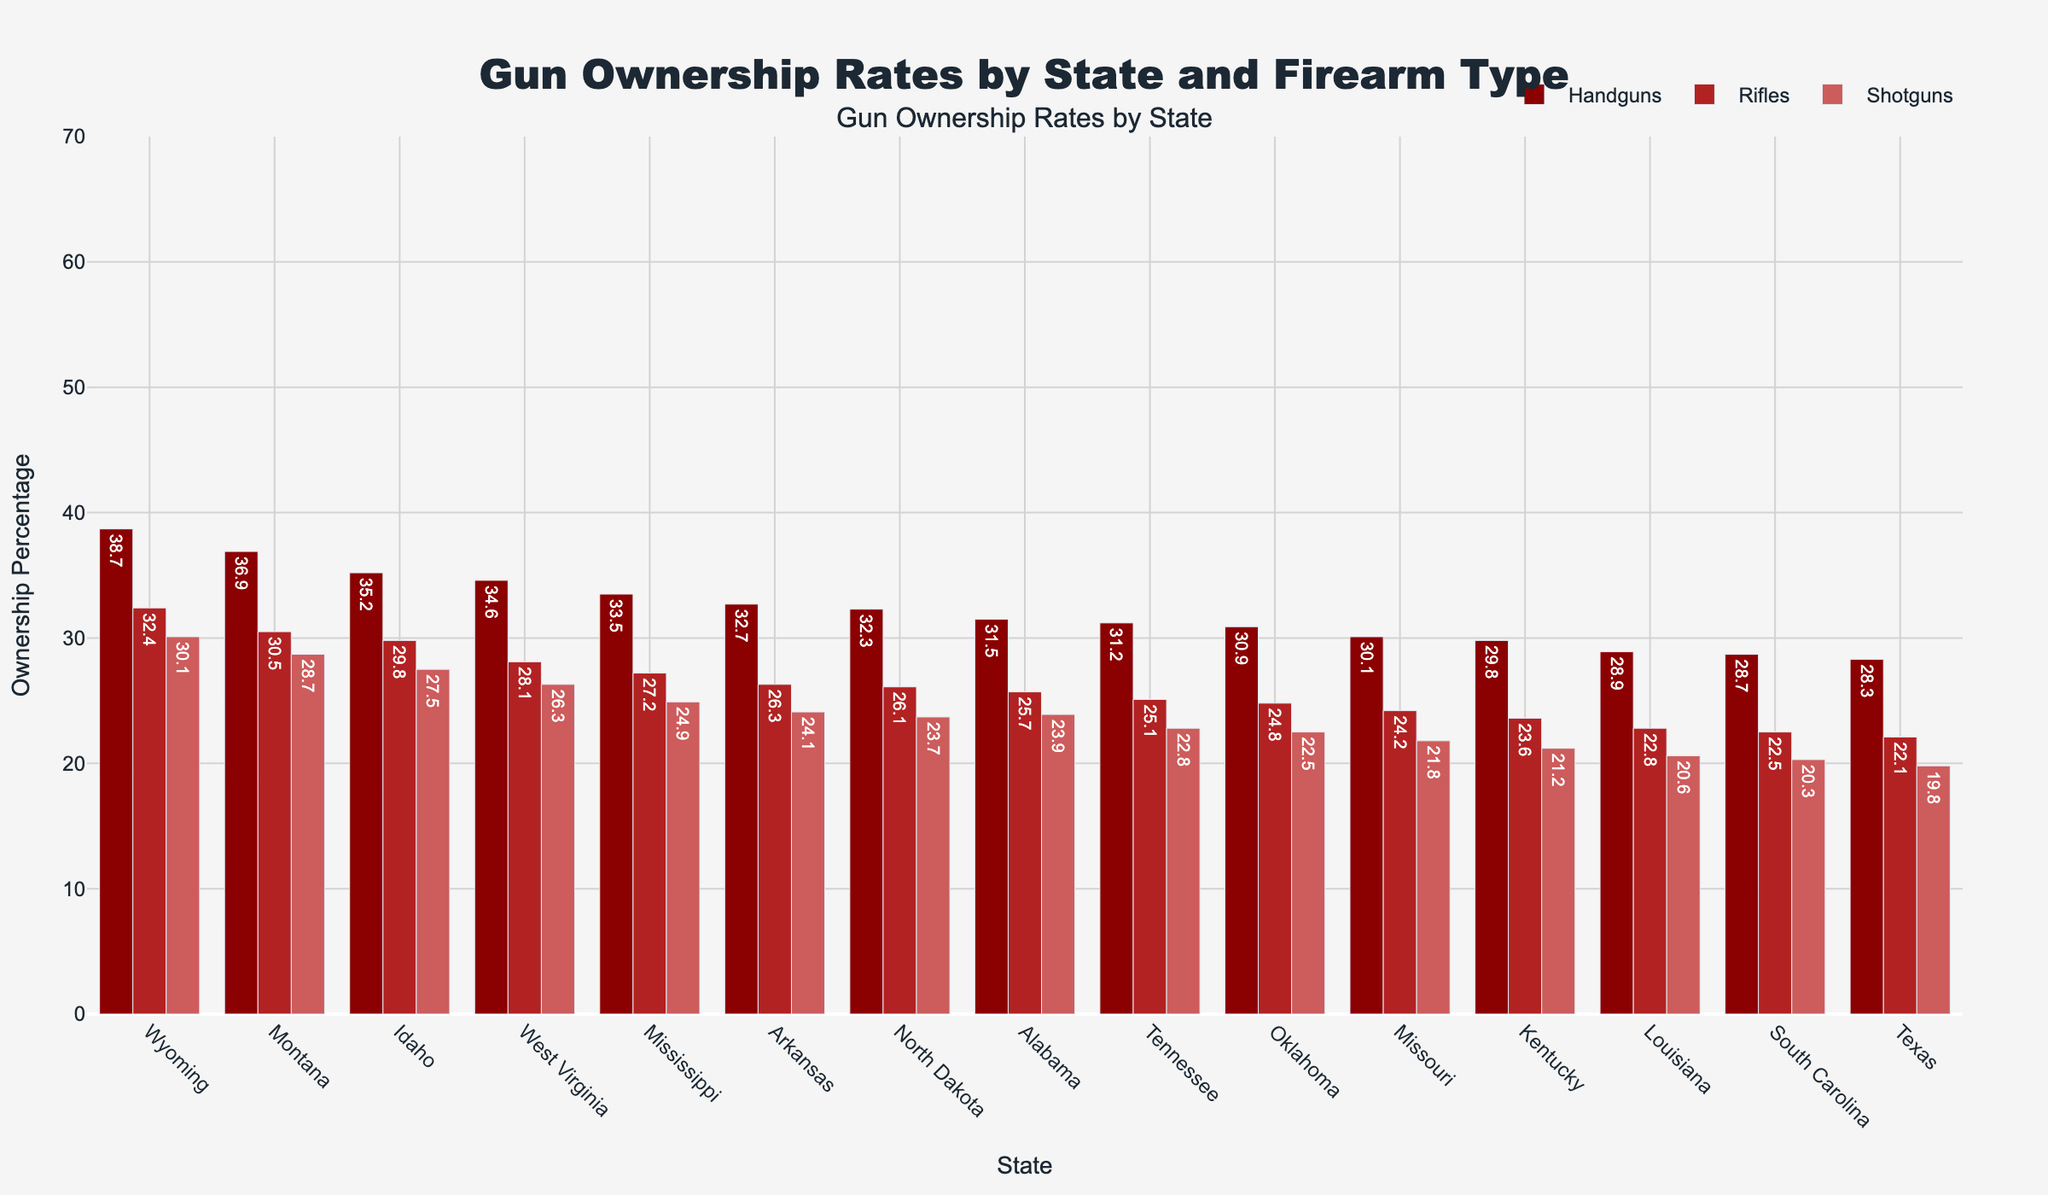How do the gun ownership rates in Texas and Wyoming compare for each type of firearm? To compare the gun ownership rates for each type of firearm in Texas and Wyoming, we look at the figure and check the bars for handguns, rifles, and shotguns for both states. Texas: Handguns 28.3%, Rifles 22.1%, Shotguns 19.8%. Wyoming: Handguns 38.7%, Rifles 32.4%, Shotguns 30.1%. So, for all types, Wyoming has higher ownership than Texas.
Answer: Wyoming has higher rates for all types Which state has the highest total gun ownership rate, and what is the percentage? By inspecting the bar with the highest total ownership percentage, we find Wyoming has the highest total gun ownership rate of 66.2%.
Answer: Wyoming, 66.2% What is the difference in handgun ownership between Alabama and Montana? The handgun ownership rates are 31.5% for Alabama and 36.9% for Montana. The difference is calculated as 36.9 - 31.5 = 5.4%.
Answer: 5.4% Which state has the lowest shotgun ownership rate, and what is the percentage? By looking at the shortest bar for shotguns, Louisiana has the lowest shotgun ownership rate at 20.6%.
Answer: Louisiana, 20.6% What is the average rifle ownership rate across all states? To find the average rifle ownership rate, sum up all the states’ rifle percentages and divide by the number of states (15). (22.1 + 25.7 + 29.8 + 32.4 + 30.5 + 23.6 + 26.3 + 24.8 + 28.1 + 27.2 + 22.8 + 24.2 + 25.1 + 22.5 + 26.1) / 15 ≈ 26.1%.
Answer: 26.1% Among Texas, Alabama, and Idaho, which state has the highest shotgun ownership rate? By comparing the shotgun ownership rates of the three states: Texas 19.8%, Alabama 23.9%, Idaho 27.5%, we see Idaho has the highest shotgun ownership among them.
Answer: Idaho What is the combined ownership percentage for handguns and rifles in West Virginia? In West Virginia, handgun ownership is 34.6% and rifle ownership is 28.1%. Adding these two percentages: 34.6 + 28.1 = 62.7%.
Answer: 62.7% For the states with a total ownership rate above 50%, what is the highest rifle ownership rate and which state does it belong to? States with total ownership rates above 50% are Alabama, Idaho, Wyoming, Montana, Arkansas, Oklahoma, West Virginia, Mississippi, and North Dakota. Among these, Wyoming has the highest rifle ownership rate at 32.4%.
Answer: Wyoming, 32.4% What is the percentage difference between the highest and lowest total gun ownership rates shown in the figure? The highest total ownership rate is 66.2% (Wyoming) and the lowest is 45.7% (Texas). The difference is 66.2 - 45.7 = 20.5%.
Answer: 20.5% How does rifle ownership in Kentucky compare to shotgun ownership in South Carolina? The rifle ownership in Kentucky is 23.6%, while the shotgun ownership in South Carolina is 20.3%. Thus, rifle ownership in Kentucky is higher by 23.6 - 20.3 = 3.3%.
Answer: Kentucky is higher by 3.3% 